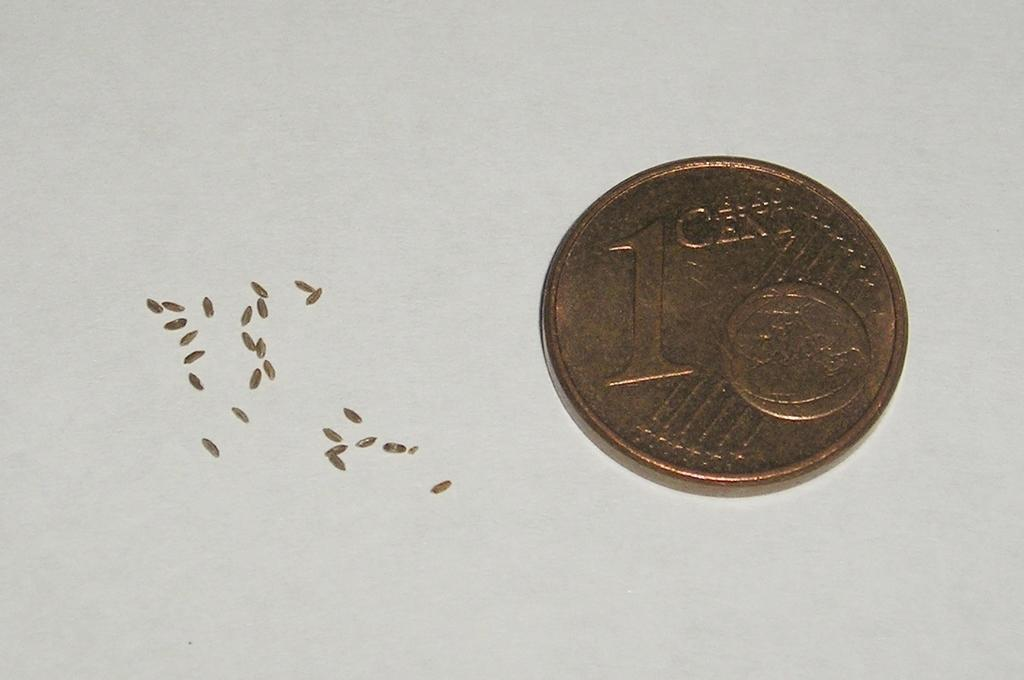<image>
Write a terse but informative summary of the picture. The back of a Euro cent is to the rice of what appears to be small grains of rice. 